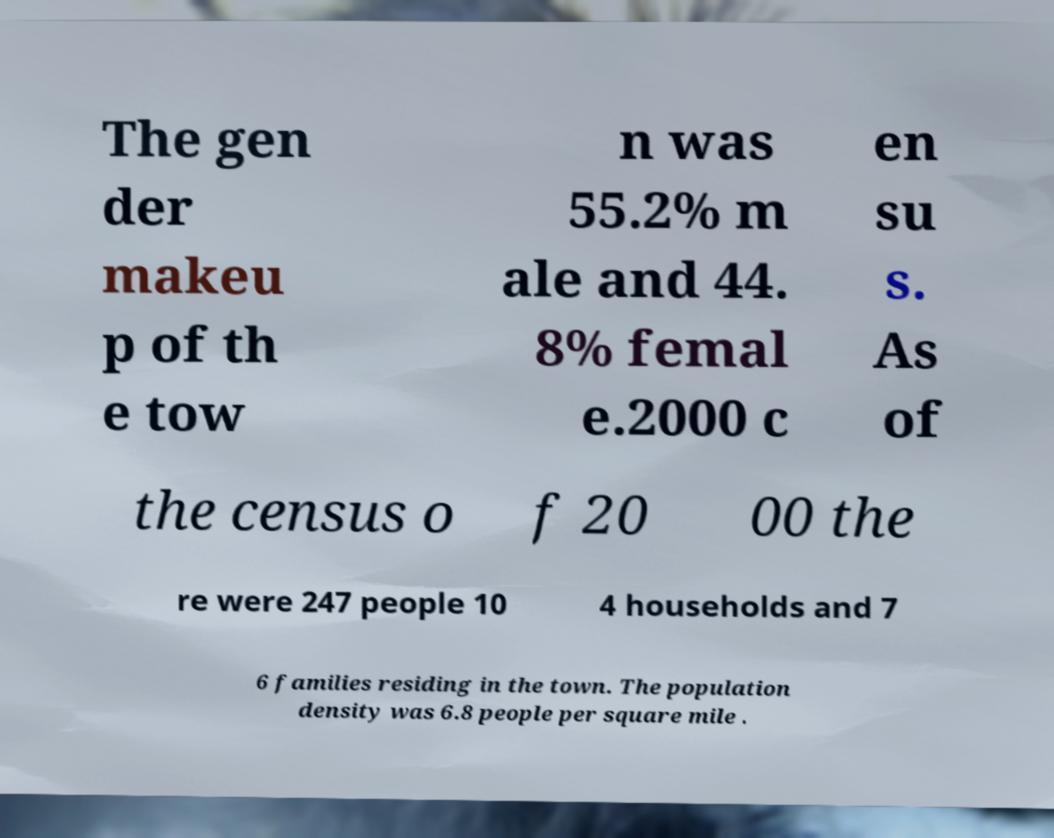What messages or text are displayed in this image? I need them in a readable, typed format. The gen der makeu p of th e tow n was 55.2% m ale and 44. 8% femal e.2000 c en su s. As of the census o f 20 00 the re were 247 people 10 4 households and 7 6 families residing in the town. The population density was 6.8 people per square mile . 